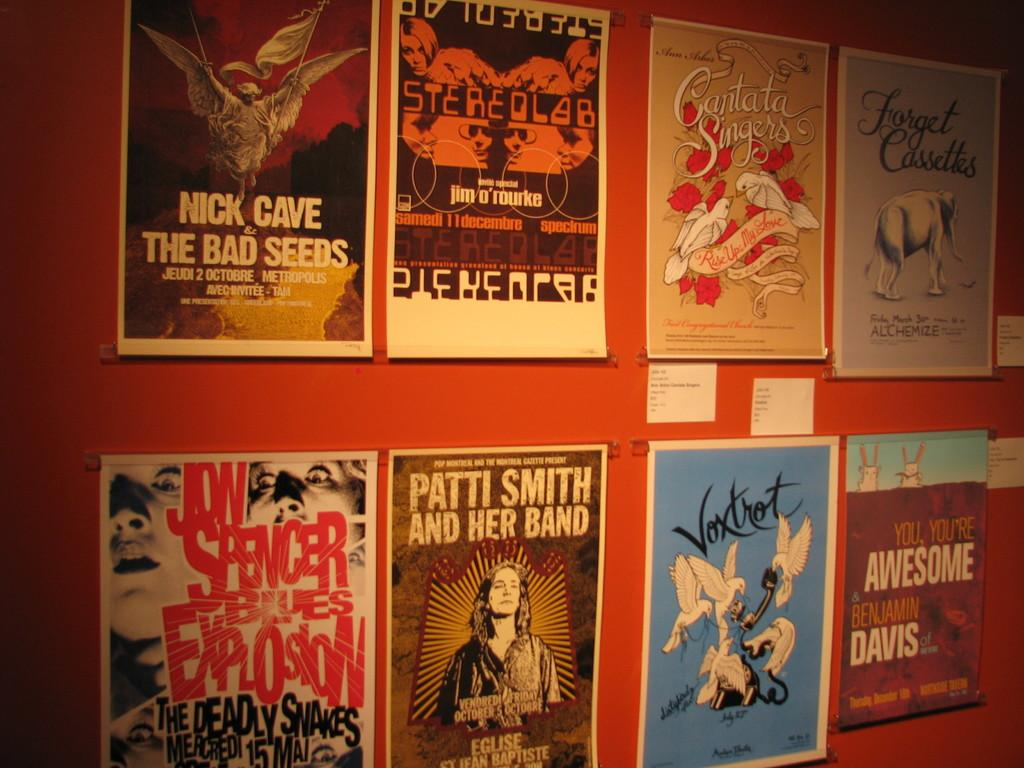Provide a one-sentence caption for the provided image. Several posters for different bands such as Patti Smith are displayed. 